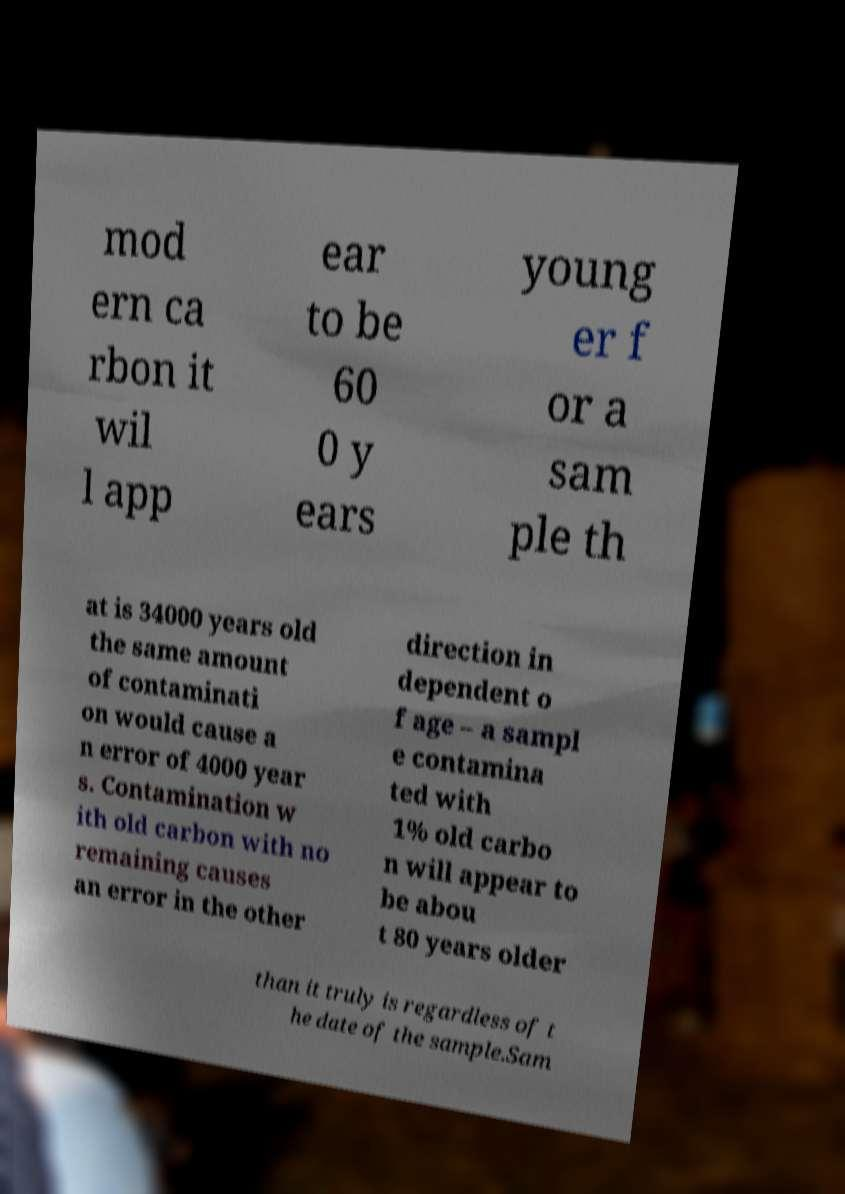Please identify and transcribe the text found in this image. mod ern ca rbon it wil l app ear to be 60 0 y ears young er f or a sam ple th at is 34000 years old the same amount of contaminati on would cause a n error of 4000 year s. Contamination w ith old carbon with no remaining causes an error in the other direction in dependent o f age – a sampl e contamina ted with 1% old carbo n will appear to be abou t 80 years older than it truly is regardless of t he date of the sample.Sam 